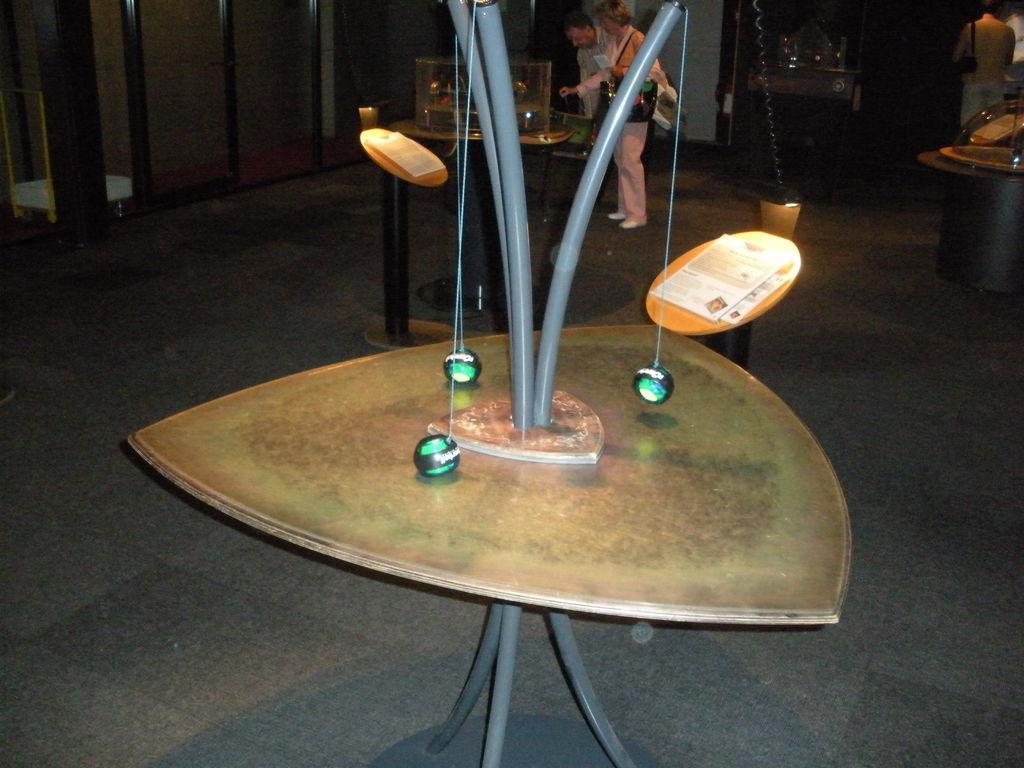Could you give a brief overview of what you see in this image? A table is kept inverted on another table. There are three balls hanged to the legs of the table. There are few people in the background. 